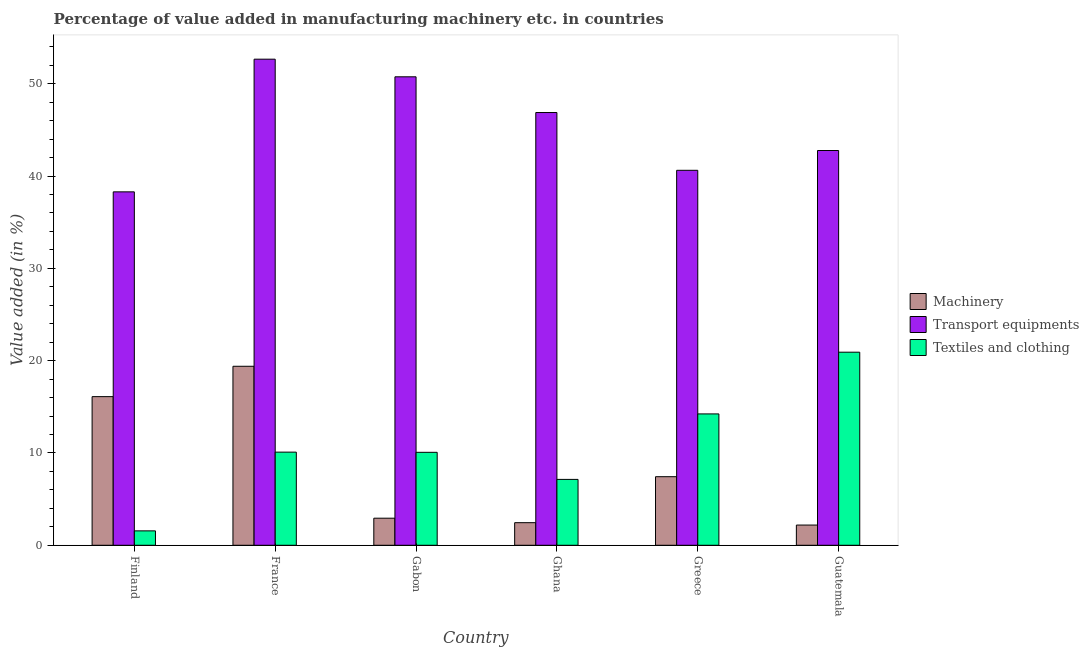How many groups of bars are there?
Offer a very short reply. 6. Are the number of bars on each tick of the X-axis equal?
Keep it short and to the point. Yes. What is the value added in manufacturing machinery in Gabon?
Your answer should be very brief. 2.93. Across all countries, what is the maximum value added in manufacturing transport equipments?
Provide a short and direct response. 52.66. Across all countries, what is the minimum value added in manufacturing machinery?
Provide a succinct answer. 2.19. In which country was the value added in manufacturing textile and clothing maximum?
Your response must be concise. Guatemala. In which country was the value added in manufacturing machinery minimum?
Your answer should be very brief. Guatemala. What is the total value added in manufacturing transport equipments in the graph?
Your response must be concise. 271.97. What is the difference between the value added in manufacturing machinery in France and that in Guatemala?
Give a very brief answer. 17.2. What is the difference between the value added in manufacturing transport equipments in Gabon and the value added in manufacturing textile and clothing in Greece?
Keep it short and to the point. 36.52. What is the average value added in manufacturing transport equipments per country?
Your answer should be very brief. 45.33. What is the difference between the value added in manufacturing transport equipments and value added in manufacturing textile and clothing in France?
Offer a terse response. 42.57. In how many countries, is the value added in manufacturing textile and clothing greater than 42 %?
Make the answer very short. 0. What is the ratio of the value added in manufacturing textile and clothing in Finland to that in Greece?
Provide a short and direct response. 0.11. What is the difference between the highest and the second highest value added in manufacturing textile and clothing?
Provide a succinct answer. 6.69. What is the difference between the highest and the lowest value added in manufacturing transport equipments?
Ensure brevity in your answer.  14.37. Is the sum of the value added in manufacturing transport equipments in France and Guatemala greater than the maximum value added in manufacturing machinery across all countries?
Ensure brevity in your answer.  Yes. What does the 2nd bar from the left in Guatemala represents?
Offer a very short reply. Transport equipments. What does the 2nd bar from the right in Guatemala represents?
Give a very brief answer. Transport equipments. Are all the bars in the graph horizontal?
Your answer should be compact. No. What is the difference between two consecutive major ticks on the Y-axis?
Offer a terse response. 10. Does the graph contain any zero values?
Offer a very short reply. No. Does the graph contain grids?
Make the answer very short. No. How are the legend labels stacked?
Your answer should be very brief. Vertical. What is the title of the graph?
Keep it short and to the point. Percentage of value added in manufacturing machinery etc. in countries. What is the label or title of the X-axis?
Ensure brevity in your answer.  Country. What is the label or title of the Y-axis?
Ensure brevity in your answer.  Value added (in %). What is the Value added (in %) of Machinery in Finland?
Your answer should be very brief. 16.1. What is the Value added (in %) in Transport equipments in Finland?
Your answer should be compact. 38.29. What is the Value added (in %) of Textiles and clothing in Finland?
Offer a terse response. 1.56. What is the Value added (in %) in Machinery in France?
Provide a short and direct response. 19.39. What is the Value added (in %) of Transport equipments in France?
Offer a very short reply. 52.66. What is the Value added (in %) in Textiles and clothing in France?
Your response must be concise. 10.09. What is the Value added (in %) in Machinery in Gabon?
Your answer should be compact. 2.93. What is the Value added (in %) in Transport equipments in Gabon?
Offer a terse response. 50.75. What is the Value added (in %) of Textiles and clothing in Gabon?
Your answer should be compact. 10.07. What is the Value added (in %) of Machinery in Ghana?
Provide a short and direct response. 2.45. What is the Value added (in %) in Transport equipments in Ghana?
Keep it short and to the point. 46.88. What is the Value added (in %) of Textiles and clothing in Ghana?
Offer a very short reply. 7.14. What is the Value added (in %) of Machinery in Greece?
Give a very brief answer. 7.43. What is the Value added (in %) in Transport equipments in Greece?
Your answer should be very brief. 40.62. What is the Value added (in %) in Textiles and clothing in Greece?
Provide a succinct answer. 14.23. What is the Value added (in %) of Machinery in Guatemala?
Ensure brevity in your answer.  2.19. What is the Value added (in %) in Transport equipments in Guatemala?
Your response must be concise. 42.77. What is the Value added (in %) in Textiles and clothing in Guatemala?
Keep it short and to the point. 20.92. Across all countries, what is the maximum Value added (in %) in Machinery?
Your answer should be compact. 19.39. Across all countries, what is the maximum Value added (in %) of Transport equipments?
Your answer should be compact. 52.66. Across all countries, what is the maximum Value added (in %) in Textiles and clothing?
Offer a terse response. 20.92. Across all countries, what is the minimum Value added (in %) in Machinery?
Offer a very short reply. 2.19. Across all countries, what is the minimum Value added (in %) in Transport equipments?
Give a very brief answer. 38.29. Across all countries, what is the minimum Value added (in %) in Textiles and clothing?
Provide a short and direct response. 1.56. What is the total Value added (in %) in Machinery in the graph?
Keep it short and to the point. 50.49. What is the total Value added (in %) of Transport equipments in the graph?
Your answer should be very brief. 271.97. What is the total Value added (in %) of Textiles and clothing in the graph?
Give a very brief answer. 64. What is the difference between the Value added (in %) of Machinery in Finland and that in France?
Provide a succinct answer. -3.29. What is the difference between the Value added (in %) of Transport equipments in Finland and that in France?
Your answer should be compact. -14.37. What is the difference between the Value added (in %) in Textiles and clothing in Finland and that in France?
Keep it short and to the point. -8.53. What is the difference between the Value added (in %) of Machinery in Finland and that in Gabon?
Give a very brief answer. 13.17. What is the difference between the Value added (in %) in Transport equipments in Finland and that in Gabon?
Make the answer very short. -12.46. What is the difference between the Value added (in %) in Textiles and clothing in Finland and that in Gabon?
Your response must be concise. -8.51. What is the difference between the Value added (in %) in Machinery in Finland and that in Ghana?
Offer a terse response. 13.65. What is the difference between the Value added (in %) of Transport equipments in Finland and that in Ghana?
Your response must be concise. -8.59. What is the difference between the Value added (in %) in Textiles and clothing in Finland and that in Ghana?
Give a very brief answer. -5.58. What is the difference between the Value added (in %) in Machinery in Finland and that in Greece?
Make the answer very short. 8.67. What is the difference between the Value added (in %) of Transport equipments in Finland and that in Greece?
Provide a short and direct response. -2.33. What is the difference between the Value added (in %) in Textiles and clothing in Finland and that in Greece?
Offer a terse response. -12.67. What is the difference between the Value added (in %) of Machinery in Finland and that in Guatemala?
Your answer should be compact. 13.91. What is the difference between the Value added (in %) in Transport equipments in Finland and that in Guatemala?
Keep it short and to the point. -4.48. What is the difference between the Value added (in %) of Textiles and clothing in Finland and that in Guatemala?
Offer a very short reply. -19.36. What is the difference between the Value added (in %) of Machinery in France and that in Gabon?
Offer a terse response. 16.46. What is the difference between the Value added (in %) of Transport equipments in France and that in Gabon?
Offer a terse response. 1.91. What is the difference between the Value added (in %) of Machinery in France and that in Ghana?
Provide a short and direct response. 16.94. What is the difference between the Value added (in %) in Transport equipments in France and that in Ghana?
Ensure brevity in your answer.  5.78. What is the difference between the Value added (in %) of Textiles and clothing in France and that in Ghana?
Your answer should be compact. 2.95. What is the difference between the Value added (in %) of Machinery in France and that in Greece?
Your response must be concise. 11.96. What is the difference between the Value added (in %) of Transport equipments in France and that in Greece?
Your answer should be compact. 12.04. What is the difference between the Value added (in %) of Textiles and clothing in France and that in Greece?
Ensure brevity in your answer.  -4.14. What is the difference between the Value added (in %) in Machinery in France and that in Guatemala?
Offer a terse response. 17.2. What is the difference between the Value added (in %) of Transport equipments in France and that in Guatemala?
Offer a terse response. 9.89. What is the difference between the Value added (in %) of Textiles and clothing in France and that in Guatemala?
Keep it short and to the point. -10.83. What is the difference between the Value added (in %) of Machinery in Gabon and that in Ghana?
Your response must be concise. 0.49. What is the difference between the Value added (in %) in Transport equipments in Gabon and that in Ghana?
Make the answer very short. 3.87. What is the difference between the Value added (in %) of Textiles and clothing in Gabon and that in Ghana?
Your answer should be compact. 2.93. What is the difference between the Value added (in %) of Machinery in Gabon and that in Greece?
Offer a terse response. -4.5. What is the difference between the Value added (in %) of Transport equipments in Gabon and that in Greece?
Offer a very short reply. 10.13. What is the difference between the Value added (in %) of Textiles and clothing in Gabon and that in Greece?
Give a very brief answer. -4.16. What is the difference between the Value added (in %) of Machinery in Gabon and that in Guatemala?
Make the answer very short. 0.74. What is the difference between the Value added (in %) of Transport equipments in Gabon and that in Guatemala?
Offer a terse response. 7.98. What is the difference between the Value added (in %) of Textiles and clothing in Gabon and that in Guatemala?
Offer a terse response. -10.85. What is the difference between the Value added (in %) in Machinery in Ghana and that in Greece?
Offer a terse response. -4.98. What is the difference between the Value added (in %) in Transport equipments in Ghana and that in Greece?
Ensure brevity in your answer.  6.26. What is the difference between the Value added (in %) of Textiles and clothing in Ghana and that in Greece?
Offer a terse response. -7.09. What is the difference between the Value added (in %) of Machinery in Ghana and that in Guatemala?
Give a very brief answer. 0.26. What is the difference between the Value added (in %) of Transport equipments in Ghana and that in Guatemala?
Your response must be concise. 4.11. What is the difference between the Value added (in %) in Textiles and clothing in Ghana and that in Guatemala?
Make the answer very short. -13.78. What is the difference between the Value added (in %) of Machinery in Greece and that in Guatemala?
Your answer should be very brief. 5.24. What is the difference between the Value added (in %) in Transport equipments in Greece and that in Guatemala?
Offer a terse response. -2.14. What is the difference between the Value added (in %) of Textiles and clothing in Greece and that in Guatemala?
Keep it short and to the point. -6.69. What is the difference between the Value added (in %) of Machinery in Finland and the Value added (in %) of Transport equipments in France?
Your answer should be very brief. -36.56. What is the difference between the Value added (in %) of Machinery in Finland and the Value added (in %) of Textiles and clothing in France?
Your response must be concise. 6.01. What is the difference between the Value added (in %) of Transport equipments in Finland and the Value added (in %) of Textiles and clothing in France?
Make the answer very short. 28.2. What is the difference between the Value added (in %) in Machinery in Finland and the Value added (in %) in Transport equipments in Gabon?
Your response must be concise. -34.65. What is the difference between the Value added (in %) of Machinery in Finland and the Value added (in %) of Textiles and clothing in Gabon?
Keep it short and to the point. 6.03. What is the difference between the Value added (in %) of Transport equipments in Finland and the Value added (in %) of Textiles and clothing in Gabon?
Keep it short and to the point. 28.22. What is the difference between the Value added (in %) of Machinery in Finland and the Value added (in %) of Transport equipments in Ghana?
Offer a very short reply. -30.78. What is the difference between the Value added (in %) in Machinery in Finland and the Value added (in %) in Textiles and clothing in Ghana?
Your answer should be compact. 8.97. What is the difference between the Value added (in %) of Transport equipments in Finland and the Value added (in %) of Textiles and clothing in Ghana?
Offer a very short reply. 31.15. What is the difference between the Value added (in %) of Machinery in Finland and the Value added (in %) of Transport equipments in Greece?
Offer a very short reply. -24.52. What is the difference between the Value added (in %) in Machinery in Finland and the Value added (in %) in Textiles and clothing in Greece?
Your answer should be compact. 1.87. What is the difference between the Value added (in %) in Transport equipments in Finland and the Value added (in %) in Textiles and clothing in Greece?
Offer a very short reply. 24.06. What is the difference between the Value added (in %) of Machinery in Finland and the Value added (in %) of Transport equipments in Guatemala?
Provide a short and direct response. -26.67. What is the difference between the Value added (in %) in Machinery in Finland and the Value added (in %) in Textiles and clothing in Guatemala?
Keep it short and to the point. -4.82. What is the difference between the Value added (in %) of Transport equipments in Finland and the Value added (in %) of Textiles and clothing in Guatemala?
Provide a short and direct response. 17.37. What is the difference between the Value added (in %) in Machinery in France and the Value added (in %) in Transport equipments in Gabon?
Ensure brevity in your answer.  -31.36. What is the difference between the Value added (in %) of Machinery in France and the Value added (in %) of Textiles and clothing in Gabon?
Your response must be concise. 9.32. What is the difference between the Value added (in %) of Transport equipments in France and the Value added (in %) of Textiles and clothing in Gabon?
Give a very brief answer. 42.59. What is the difference between the Value added (in %) in Machinery in France and the Value added (in %) in Transport equipments in Ghana?
Keep it short and to the point. -27.49. What is the difference between the Value added (in %) in Machinery in France and the Value added (in %) in Textiles and clothing in Ghana?
Your response must be concise. 12.26. What is the difference between the Value added (in %) in Transport equipments in France and the Value added (in %) in Textiles and clothing in Ghana?
Offer a terse response. 45.52. What is the difference between the Value added (in %) of Machinery in France and the Value added (in %) of Transport equipments in Greece?
Provide a short and direct response. -21.23. What is the difference between the Value added (in %) of Machinery in France and the Value added (in %) of Textiles and clothing in Greece?
Give a very brief answer. 5.16. What is the difference between the Value added (in %) of Transport equipments in France and the Value added (in %) of Textiles and clothing in Greece?
Give a very brief answer. 38.43. What is the difference between the Value added (in %) of Machinery in France and the Value added (in %) of Transport equipments in Guatemala?
Your response must be concise. -23.38. What is the difference between the Value added (in %) in Machinery in France and the Value added (in %) in Textiles and clothing in Guatemala?
Your response must be concise. -1.53. What is the difference between the Value added (in %) in Transport equipments in France and the Value added (in %) in Textiles and clothing in Guatemala?
Offer a terse response. 31.74. What is the difference between the Value added (in %) in Machinery in Gabon and the Value added (in %) in Transport equipments in Ghana?
Your answer should be compact. -43.95. What is the difference between the Value added (in %) in Machinery in Gabon and the Value added (in %) in Textiles and clothing in Ghana?
Provide a succinct answer. -4.2. What is the difference between the Value added (in %) of Transport equipments in Gabon and the Value added (in %) of Textiles and clothing in Ghana?
Ensure brevity in your answer.  43.61. What is the difference between the Value added (in %) in Machinery in Gabon and the Value added (in %) in Transport equipments in Greece?
Ensure brevity in your answer.  -37.69. What is the difference between the Value added (in %) of Machinery in Gabon and the Value added (in %) of Textiles and clothing in Greece?
Provide a short and direct response. -11.3. What is the difference between the Value added (in %) of Transport equipments in Gabon and the Value added (in %) of Textiles and clothing in Greece?
Offer a very short reply. 36.52. What is the difference between the Value added (in %) in Machinery in Gabon and the Value added (in %) in Transport equipments in Guatemala?
Make the answer very short. -39.83. What is the difference between the Value added (in %) in Machinery in Gabon and the Value added (in %) in Textiles and clothing in Guatemala?
Ensure brevity in your answer.  -17.98. What is the difference between the Value added (in %) in Transport equipments in Gabon and the Value added (in %) in Textiles and clothing in Guatemala?
Ensure brevity in your answer.  29.83. What is the difference between the Value added (in %) in Machinery in Ghana and the Value added (in %) in Transport equipments in Greece?
Your answer should be very brief. -38.17. What is the difference between the Value added (in %) of Machinery in Ghana and the Value added (in %) of Textiles and clothing in Greece?
Your response must be concise. -11.78. What is the difference between the Value added (in %) in Transport equipments in Ghana and the Value added (in %) in Textiles and clothing in Greece?
Your response must be concise. 32.65. What is the difference between the Value added (in %) of Machinery in Ghana and the Value added (in %) of Transport equipments in Guatemala?
Keep it short and to the point. -40.32. What is the difference between the Value added (in %) of Machinery in Ghana and the Value added (in %) of Textiles and clothing in Guatemala?
Your answer should be very brief. -18.47. What is the difference between the Value added (in %) of Transport equipments in Ghana and the Value added (in %) of Textiles and clothing in Guatemala?
Provide a short and direct response. 25.96. What is the difference between the Value added (in %) of Machinery in Greece and the Value added (in %) of Transport equipments in Guatemala?
Your response must be concise. -35.34. What is the difference between the Value added (in %) in Machinery in Greece and the Value added (in %) in Textiles and clothing in Guatemala?
Your answer should be compact. -13.49. What is the difference between the Value added (in %) in Transport equipments in Greece and the Value added (in %) in Textiles and clothing in Guatemala?
Offer a very short reply. 19.71. What is the average Value added (in %) of Machinery per country?
Your answer should be compact. 8.42. What is the average Value added (in %) of Transport equipments per country?
Provide a short and direct response. 45.33. What is the average Value added (in %) of Textiles and clothing per country?
Give a very brief answer. 10.67. What is the difference between the Value added (in %) of Machinery and Value added (in %) of Transport equipments in Finland?
Provide a succinct answer. -22.19. What is the difference between the Value added (in %) of Machinery and Value added (in %) of Textiles and clothing in Finland?
Your answer should be compact. 14.54. What is the difference between the Value added (in %) in Transport equipments and Value added (in %) in Textiles and clothing in Finland?
Your answer should be very brief. 36.73. What is the difference between the Value added (in %) in Machinery and Value added (in %) in Transport equipments in France?
Offer a very short reply. -33.27. What is the difference between the Value added (in %) of Machinery and Value added (in %) of Textiles and clothing in France?
Offer a terse response. 9.3. What is the difference between the Value added (in %) of Transport equipments and Value added (in %) of Textiles and clothing in France?
Your response must be concise. 42.57. What is the difference between the Value added (in %) of Machinery and Value added (in %) of Transport equipments in Gabon?
Provide a short and direct response. -47.82. What is the difference between the Value added (in %) of Machinery and Value added (in %) of Textiles and clothing in Gabon?
Offer a terse response. -7.14. What is the difference between the Value added (in %) in Transport equipments and Value added (in %) in Textiles and clothing in Gabon?
Provide a short and direct response. 40.68. What is the difference between the Value added (in %) of Machinery and Value added (in %) of Transport equipments in Ghana?
Make the answer very short. -44.43. What is the difference between the Value added (in %) in Machinery and Value added (in %) in Textiles and clothing in Ghana?
Make the answer very short. -4.69. What is the difference between the Value added (in %) in Transport equipments and Value added (in %) in Textiles and clothing in Ghana?
Your answer should be very brief. 39.75. What is the difference between the Value added (in %) in Machinery and Value added (in %) in Transport equipments in Greece?
Ensure brevity in your answer.  -33.19. What is the difference between the Value added (in %) of Machinery and Value added (in %) of Textiles and clothing in Greece?
Offer a very short reply. -6.8. What is the difference between the Value added (in %) in Transport equipments and Value added (in %) in Textiles and clothing in Greece?
Offer a terse response. 26.39. What is the difference between the Value added (in %) of Machinery and Value added (in %) of Transport equipments in Guatemala?
Your answer should be compact. -40.58. What is the difference between the Value added (in %) of Machinery and Value added (in %) of Textiles and clothing in Guatemala?
Make the answer very short. -18.73. What is the difference between the Value added (in %) of Transport equipments and Value added (in %) of Textiles and clothing in Guatemala?
Your response must be concise. 21.85. What is the ratio of the Value added (in %) in Machinery in Finland to that in France?
Provide a short and direct response. 0.83. What is the ratio of the Value added (in %) of Transport equipments in Finland to that in France?
Keep it short and to the point. 0.73. What is the ratio of the Value added (in %) in Textiles and clothing in Finland to that in France?
Offer a very short reply. 0.15. What is the ratio of the Value added (in %) in Machinery in Finland to that in Gabon?
Provide a short and direct response. 5.49. What is the ratio of the Value added (in %) of Transport equipments in Finland to that in Gabon?
Provide a short and direct response. 0.75. What is the ratio of the Value added (in %) in Textiles and clothing in Finland to that in Gabon?
Ensure brevity in your answer.  0.15. What is the ratio of the Value added (in %) of Machinery in Finland to that in Ghana?
Keep it short and to the point. 6.58. What is the ratio of the Value added (in %) of Transport equipments in Finland to that in Ghana?
Provide a short and direct response. 0.82. What is the ratio of the Value added (in %) of Textiles and clothing in Finland to that in Ghana?
Offer a terse response. 0.22. What is the ratio of the Value added (in %) in Machinery in Finland to that in Greece?
Your answer should be compact. 2.17. What is the ratio of the Value added (in %) in Transport equipments in Finland to that in Greece?
Ensure brevity in your answer.  0.94. What is the ratio of the Value added (in %) in Textiles and clothing in Finland to that in Greece?
Offer a very short reply. 0.11. What is the ratio of the Value added (in %) of Machinery in Finland to that in Guatemala?
Keep it short and to the point. 7.35. What is the ratio of the Value added (in %) in Transport equipments in Finland to that in Guatemala?
Provide a short and direct response. 0.9. What is the ratio of the Value added (in %) of Textiles and clothing in Finland to that in Guatemala?
Offer a terse response. 0.07. What is the ratio of the Value added (in %) in Machinery in France to that in Gabon?
Your answer should be compact. 6.61. What is the ratio of the Value added (in %) of Transport equipments in France to that in Gabon?
Your response must be concise. 1.04. What is the ratio of the Value added (in %) in Machinery in France to that in Ghana?
Give a very brief answer. 7.92. What is the ratio of the Value added (in %) of Transport equipments in France to that in Ghana?
Provide a succinct answer. 1.12. What is the ratio of the Value added (in %) of Textiles and clothing in France to that in Ghana?
Provide a short and direct response. 1.41. What is the ratio of the Value added (in %) of Machinery in France to that in Greece?
Provide a short and direct response. 2.61. What is the ratio of the Value added (in %) of Transport equipments in France to that in Greece?
Ensure brevity in your answer.  1.3. What is the ratio of the Value added (in %) of Textiles and clothing in France to that in Greece?
Provide a succinct answer. 0.71. What is the ratio of the Value added (in %) of Machinery in France to that in Guatemala?
Keep it short and to the point. 8.85. What is the ratio of the Value added (in %) of Transport equipments in France to that in Guatemala?
Offer a terse response. 1.23. What is the ratio of the Value added (in %) of Textiles and clothing in France to that in Guatemala?
Provide a short and direct response. 0.48. What is the ratio of the Value added (in %) of Machinery in Gabon to that in Ghana?
Your answer should be compact. 1.2. What is the ratio of the Value added (in %) in Transport equipments in Gabon to that in Ghana?
Ensure brevity in your answer.  1.08. What is the ratio of the Value added (in %) of Textiles and clothing in Gabon to that in Ghana?
Provide a succinct answer. 1.41. What is the ratio of the Value added (in %) of Machinery in Gabon to that in Greece?
Make the answer very short. 0.39. What is the ratio of the Value added (in %) of Transport equipments in Gabon to that in Greece?
Your answer should be compact. 1.25. What is the ratio of the Value added (in %) in Textiles and clothing in Gabon to that in Greece?
Your answer should be compact. 0.71. What is the ratio of the Value added (in %) in Machinery in Gabon to that in Guatemala?
Provide a short and direct response. 1.34. What is the ratio of the Value added (in %) of Transport equipments in Gabon to that in Guatemala?
Give a very brief answer. 1.19. What is the ratio of the Value added (in %) in Textiles and clothing in Gabon to that in Guatemala?
Provide a short and direct response. 0.48. What is the ratio of the Value added (in %) of Machinery in Ghana to that in Greece?
Provide a succinct answer. 0.33. What is the ratio of the Value added (in %) of Transport equipments in Ghana to that in Greece?
Provide a short and direct response. 1.15. What is the ratio of the Value added (in %) in Textiles and clothing in Ghana to that in Greece?
Offer a very short reply. 0.5. What is the ratio of the Value added (in %) of Machinery in Ghana to that in Guatemala?
Your answer should be compact. 1.12. What is the ratio of the Value added (in %) in Transport equipments in Ghana to that in Guatemala?
Your answer should be compact. 1.1. What is the ratio of the Value added (in %) of Textiles and clothing in Ghana to that in Guatemala?
Your response must be concise. 0.34. What is the ratio of the Value added (in %) of Machinery in Greece to that in Guatemala?
Offer a very short reply. 3.39. What is the ratio of the Value added (in %) in Transport equipments in Greece to that in Guatemala?
Your answer should be very brief. 0.95. What is the ratio of the Value added (in %) of Textiles and clothing in Greece to that in Guatemala?
Ensure brevity in your answer.  0.68. What is the difference between the highest and the second highest Value added (in %) of Machinery?
Your answer should be compact. 3.29. What is the difference between the highest and the second highest Value added (in %) of Transport equipments?
Ensure brevity in your answer.  1.91. What is the difference between the highest and the second highest Value added (in %) in Textiles and clothing?
Make the answer very short. 6.69. What is the difference between the highest and the lowest Value added (in %) of Machinery?
Offer a very short reply. 17.2. What is the difference between the highest and the lowest Value added (in %) in Transport equipments?
Your response must be concise. 14.37. What is the difference between the highest and the lowest Value added (in %) in Textiles and clothing?
Provide a short and direct response. 19.36. 